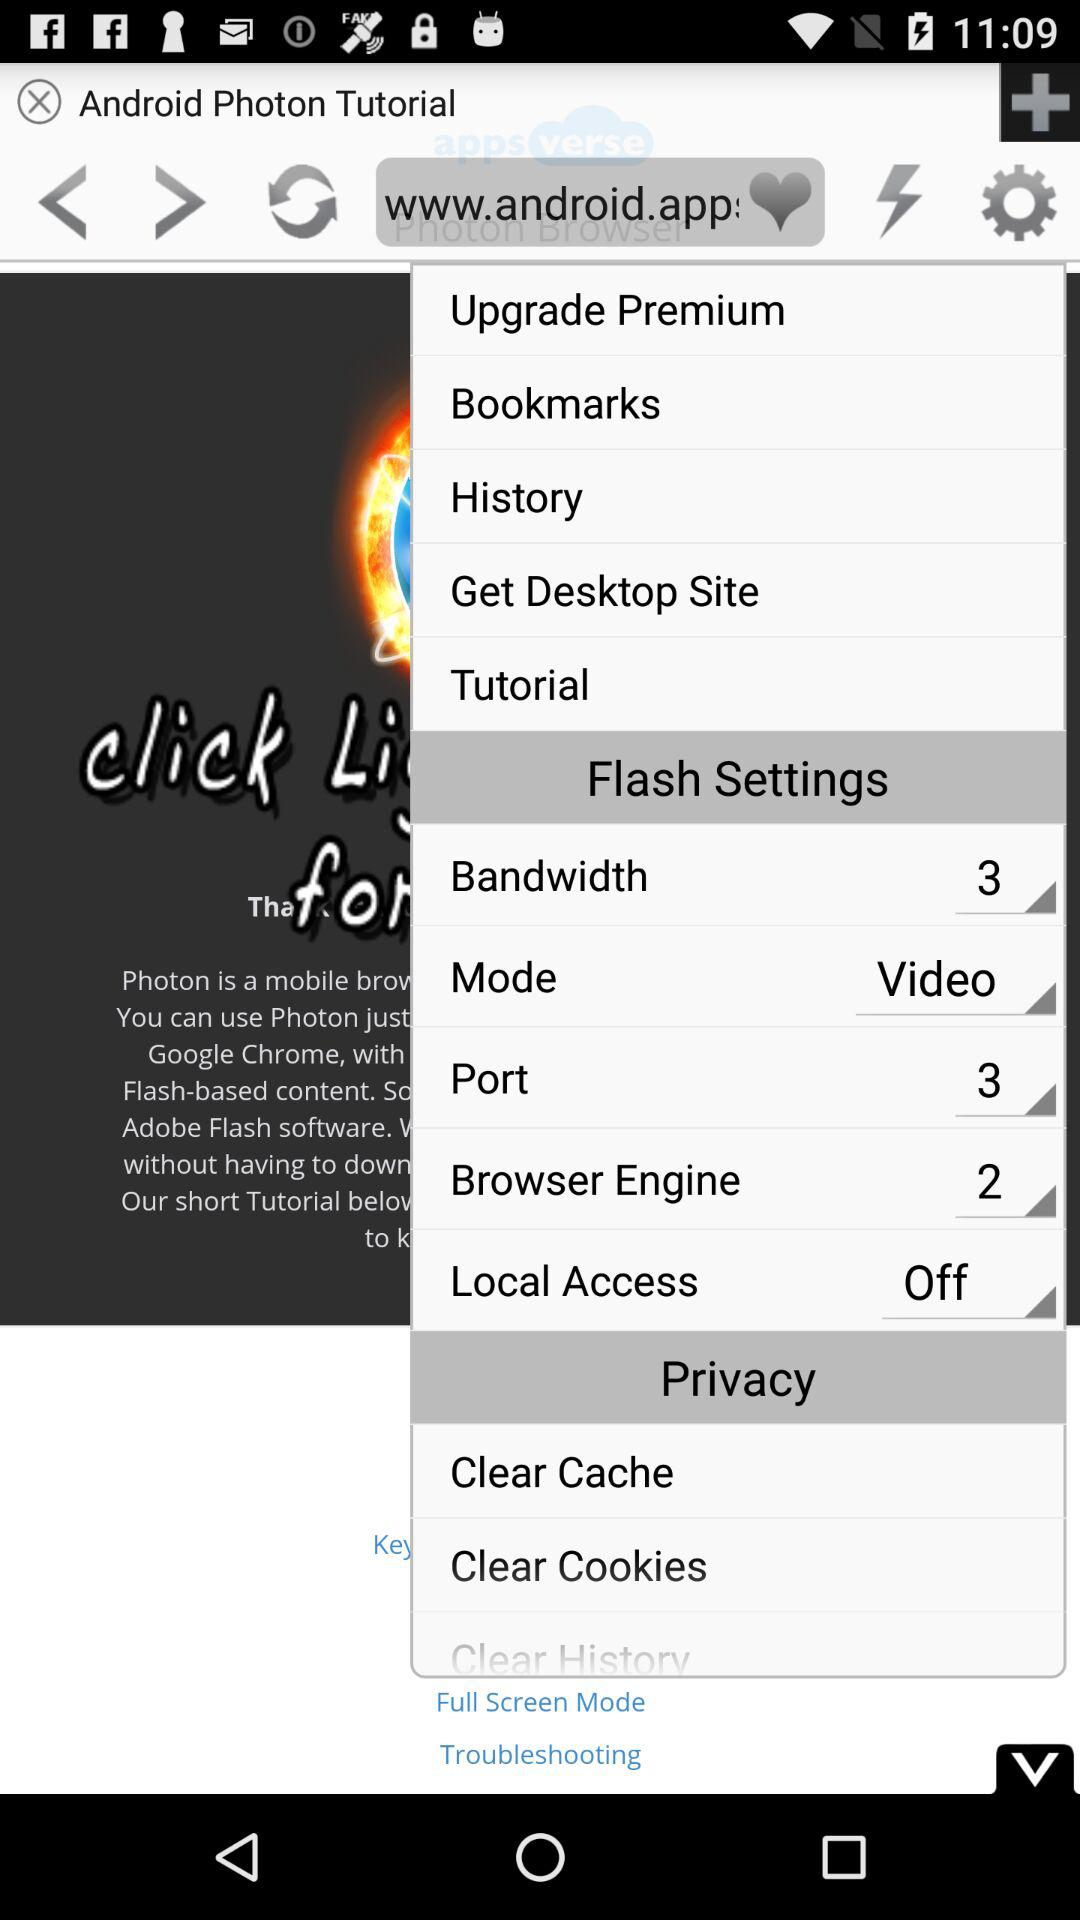What is the bandwidth? The bandwidth is three. 